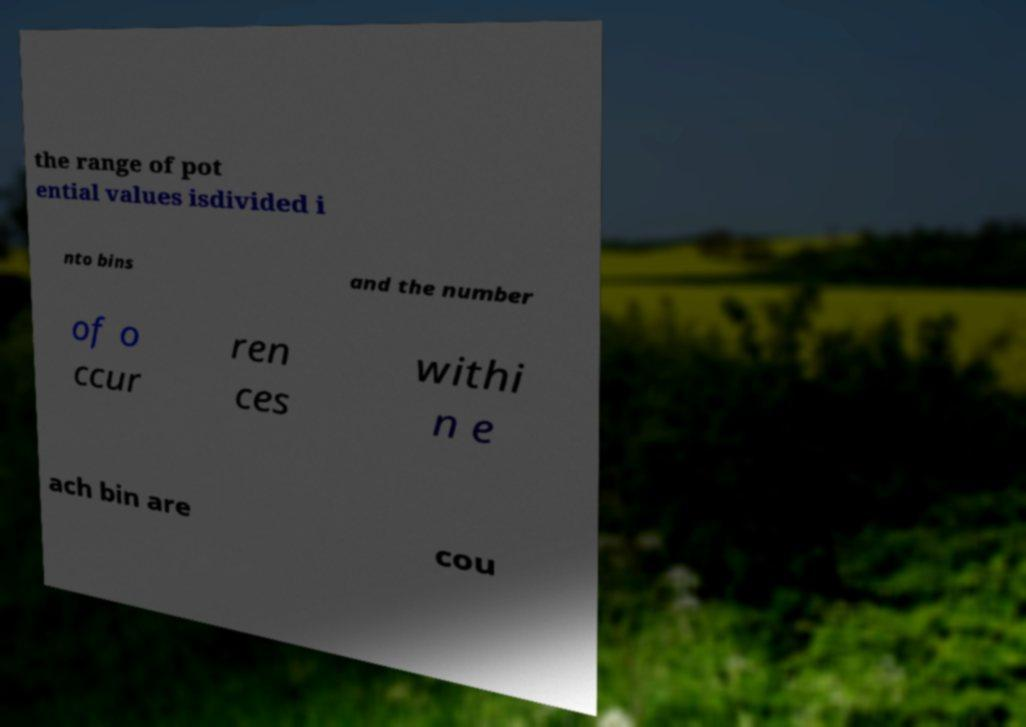Please identify and transcribe the text found in this image. the range of pot ential values isdivided i nto bins and the number of o ccur ren ces withi n e ach bin are cou 